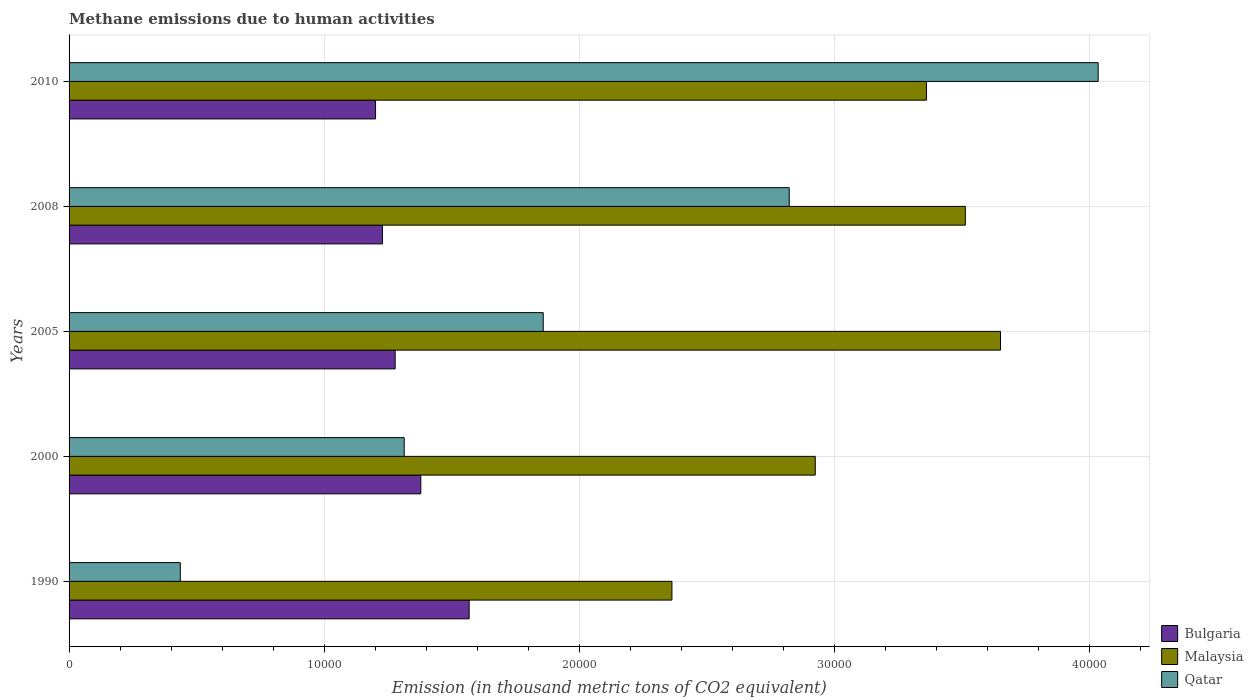How many groups of bars are there?
Offer a terse response. 5. Are the number of bars per tick equal to the number of legend labels?
Make the answer very short. Yes. Are the number of bars on each tick of the Y-axis equal?
Offer a very short reply. Yes. What is the amount of methane emitted in Malaysia in 1990?
Make the answer very short. 2.36e+04. Across all years, what is the maximum amount of methane emitted in Bulgaria?
Your answer should be very brief. 1.57e+04. Across all years, what is the minimum amount of methane emitted in Malaysia?
Give a very brief answer. 2.36e+04. In which year was the amount of methane emitted in Malaysia maximum?
Give a very brief answer. 2005. In which year was the amount of methane emitted in Qatar minimum?
Keep it short and to the point. 1990. What is the total amount of methane emitted in Bulgaria in the graph?
Provide a short and direct response. 6.65e+04. What is the difference between the amount of methane emitted in Bulgaria in 2000 and that in 2005?
Your answer should be very brief. 1004.9. What is the difference between the amount of methane emitted in Qatar in 2005 and the amount of methane emitted in Malaysia in 2000?
Give a very brief answer. -1.07e+04. What is the average amount of methane emitted in Qatar per year?
Offer a terse response. 2.09e+04. In the year 2005, what is the difference between the amount of methane emitted in Malaysia and amount of methane emitted in Qatar?
Your answer should be very brief. 1.79e+04. In how many years, is the amount of methane emitted in Bulgaria greater than 16000 thousand metric tons?
Give a very brief answer. 0. What is the ratio of the amount of methane emitted in Qatar in 2008 to that in 2010?
Ensure brevity in your answer.  0.7. What is the difference between the highest and the second highest amount of methane emitted in Malaysia?
Provide a succinct answer. 1378.2. What is the difference between the highest and the lowest amount of methane emitted in Qatar?
Your answer should be very brief. 3.60e+04. In how many years, is the amount of methane emitted in Qatar greater than the average amount of methane emitted in Qatar taken over all years?
Offer a terse response. 2. What does the 2nd bar from the top in 1990 represents?
Offer a very short reply. Malaysia. What does the 3rd bar from the bottom in 1990 represents?
Provide a short and direct response. Qatar. How many bars are there?
Your answer should be compact. 15. Are all the bars in the graph horizontal?
Keep it short and to the point. Yes. How many years are there in the graph?
Offer a very short reply. 5. How many legend labels are there?
Give a very brief answer. 3. How are the legend labels stacked?
Your answer should be compact. Vertical. What is the title of the graph?
Ensure brevity in your answer.  Methane emissions due to human activities. Does "Lao PDR" appear as one of the legend labels in the graph?
Your response must be concise. No. What is the label or title of the X-axis?
Your answer should be very brief. Emission (in thousand metric tons of CO2 equivalent). What is the Emission (in thousand metric tons of CO2 equivalent) in Bulgaria in 1990?
Provide a succinct answer. 1.57e+04. What is the Emission (in thousand metric tons of CO2 equivalent) in Malaysia in 1990?
Offer a terse response. 2.36e+04. What is the Emission (in thousand metric tons of CO2 equivalent) of Qatar in 1990?
Your answer should be compact. 4358.8. What is the Emission (in thousand metric tons of CO2 equivalent) in Bulgaria in 2000?
Offer a terse response. 1.38e+04. What is the Emission (in thousand metric tons of CO2 equivalent) of Malaysia in 2000?
Offer a terse response. 2.92e+04. What is the Emission (in thousand metric tons of CO2 equivalent) of Qatar in 2000?
Your answer should be very brief. 1.31e+04. What is the Emission (in thousand metric tons of CO2 equivalent) in Bulgaria in 2005?
Your response must be concise. 1.28e+04. What is the Emission (in thousand metric tons of CO2 equivalent) in Malaysia in 2005?
Make the answer very short. 3.65e+04. What is the Emission (in thousand metric tons of CO2 equivalent) of Qatar in 2005?
Your answer should be compact. 1.86e+04. What is the Emission (in thousand metric tons of CO2 equivalent) of Bulgaria in 2008?
Provide a short and direct response. 1.23e+04. What is the Emission (in thousand metric tons of CO2 equivalent) in Malaysia in 2008?
Ensure brevity in your answer.  3.51e+04. What is the Emission (in thousand metric tons of CO2 equivalent) of Qatar in 2008?
Keep it short and to the point. 2.82e+04. What is the Emission (in thousand metric tons of CO2 equivalent) in Bulgaria in 2010?
Provide a short and direct response. 1.20e+04. What is the Emission (in thousand metric tons of CO2 equivalent) in Malaysia in 2010?
Your answer should be compact. 3.36e+04. What is the Emission (in thousand metric tons of CO2 equivalent) in Qatar in 2010?
Ensure brevity in your answer.  4.03e+04. Across all years, what is the maximum Emission (in thousand metric tons of CO2 equivalent) in Bulgaria?
Keep it short and to the point. 1.57e+04. Across all years, what is the maximum Emission (in thousand metric tons of CO2 equivalent) in Malaysia?
Make the answer very short. 3.65e+04. Across all years, what is the maximum Emission (in thousand metric tons of CO2 equivalent) of Qatar?
Offer a terse response. 4.03e+04. Across all years, what is the minimum Emission (in thousand metric tons of CO2 equivalent) in Bulgaria?
Your response must be concise. 1.20e+04. Across all years, what is the minimum Emission (in thousand metric tons of CO2 equivalent) of Malaysia?
Your answer should be compact. 2.36e+04. Across all years, what is the minimum Emission (in thousand metric tons of CO2 equivalent) in Qatar?
Provide a succinct answer. 4358.8. What is the total Emission (in thousand metric tons of CO2 equivalent) in Bulgaria in the graph?
Make the answer very short. 6.65e+04. What is the total Emission (in thousand metric tons of CO2 equivalent) in Malaysia in the graph?
Provide a succinct answer. 1.58e+05. What is the total Emission (in thousand metric tons of CO2 equivalent) in Qatar in the graph?
Provide a short and direct response. 1.05e+05. What is the difference between the Emission (in thousand metric tons of CO2 equivalent) of Bulgaria in 1990 and that in 2000?
Give a very brief answer. 1894.2. What is the difference between the Emission (in thousand metric tons of CO2 equivalent) in Malaysia in 1990 and that in 2000?
Provide a succinct answer. -5617.1. What is the difference between the Emission (in thousand metric tons of CO2 equivalent) in Qatar in 1990 and that in 2000?
Provide a short and direct response. -8774.7. What is the difference between the Emission (in thousand metric tons of CO2 equivalent) of Bulgaria in 1990 and that in 2005?
Ensure brevity in your answer.  2899.1. What is the difference between the Emission (in thousand metric tons of CO2 equivalent) in Malaysia in 1990 and that in 2005?
Offer a very short reply. -1.29e+04. What is the difference between the Emission (in thousand metric tons of CO2 equivalent) in Qatar in 1990 and that in 2005?
Offer a very short reply. -1.42e+04. What is the difference between the Emission (in thousand metric tons of CO2 equivalent) of Bulgaria in 1990 and that in 2008?
Offer a very short reply. 3397.3. What is the difference between the Emission (in thousand metric tons of CO2 equivalent) of Malaysia in 1990 and that in 2008?
Offer a very short reply. -1.15e+04. What is the difference between the Emission (in thousand metric tons of CO2 equivalent) in Qatar in 1990 and that in 2008?
Provide a short and direct response. -2.39e+04. What is the difference between the Emission (in thousand metric tons of CO2 equivalent) of Bulgaria in 1990 and that in 2010?
Provide a succinct answer. 3666.9. What is the difference between the Emission (in thousand metric tons of CO2 equivalent) in Malaysia in 1990 and that in 2010?
Provide a succinct answer. -9974.2. What is the difference between the Emission (in thousand metric tons of CO2 equivalent) of Qatar in 1990 and that in 2010?
Provide a succinct answer. -3.60e+04. What is the difference between the Emission (in thousand metric tons of CO2 equivalent) in Bulgaria in 2000 and that in 2005?
Your answer should be compact. 1004.9. What is the difference between the Emission (in thousand metric tons of CO2 equivalent) in Malaysia in 2000 and that in 2005?
Provide a short and direct response. -7258.7. What is the difference between the Emission (in thousand metric tons of CO2 equivalent) in Qatar in 2000 and that in 2005?
Keep it short and to the point. -5447.2. What is the difference between the Emission (in thousand metric tons of CO2 equivalent) in Bulgaria in 2000 and that in 2008?
Provide a succinct answer. 1503.1. What is the difference between the Emission (in thousand metric tons of CO2 equivalent) in Malaysia in 2000 and that in 2008?
Make the answer very short. -5880.5. What is the difference between the Emission (in thousand metric tons of CO2 equivalent) in Qatar in 2000 and that in 2008?
Your answer should be very brief. -1.51e+04. What is the difference between the Emission (in thousand metric tons of CO2 equivalent) in Bulgaria in 2000 and that in 2010?
Your answer should be compact. 1772.7. What is the difference between the Emission (in thousand metric tons of CO2 equivalent) of Malaysia in 2000 and that in 2010?
Offer a terse response. -4357.1. What is the difference between the Emission (in thousand metric tons of CO2 equivalent) of Qatar in 2000 and that in 2010?
Offer a terse response. -2.72e+04. What is the difference between the Emission (in thousand metric tons of CO2 equivalent) in Bulgaria in 2005 and that in 2008?
Your response must be concise. 498.2. What is the difference between the Emission (in thousand metric tons of CO2 equivalent) of Malaysia in 2005 and that in 2008?
Offer a terse response. 1378.2. What is the difference between the Emission (in thousand metric tons of CO2 equivalent) of Qatar in 2005 and that in 2008?
Your answer should be very brief. -9640.9. What is the difference between the Emission (in thousand metric tons of CO2 equivalent) in Bulgaria in 2005 and that in 2010?
Ensure brevity in your answer.  767.8. What is the difference between the Emission (in thousand metric tons of CO2 equivalent) of Malaysia in 2005 and that in 2010?
Keep it short and to the point. 2901.6. What is the difference between the Emission (in thousand metric tons of CO2 equivalent) in Qatar in 2005 and that in 2010?
Your response must be concise. -2.17e+04. What is the difference between the Emission (in thousand metric tons of CO2 equivalent) of Bulgaria in 2008 and that in 2010?
Provide a succinct answer. 269.6. What is the difference between the Emission (in thousand metric tons of CO2 equivalent) of Malaysia in 2008 and that in 2010?
Your answer should be very brief. 1523.4. What is the difference between the Emission (in thousand metric tons of CO2 equivalent) in Qatar in 2008 and that in 2010?
Your answer should be very brief. -1.21e+04. What is the difference between the Emission (in thousand metric tons of CO2 equivalent) of Bulgaria in 1990 and the Emission (in thousand metric tons of CO2 equivalent) of Malaysia in 2000?
Offer a terse response. -1.36e+04. What is the difference between the Emission (in thousand metric tons of CO2 equivalent) of Bulgaria in 1990 and the Emission (in thousand metric tons of CO2 equivalent) of Qatar in 2000?
Give a very brief answer. 2544. What is the difference between the Emission (in thousand metric tons of CO2 equivalent) of Malaysia in 1990 and the Emission (in thousand metric tons of CO2 equivalent) of Qatar in 2000?
Offer a terse response. 1.05e+04. What is the difference between the Emission (in thousand metric tons of CO2 equivalent) in Bulgaria in 1990 and the Emission (in thousand metric tons of CO2 equivalent) in Malaysia in 2005?
Your answer should be very brief. -2.08e+04. What is the difference between the Emission (in thousand metric tons of CO2 equivalent) of Bulgaria in 1990 and the Emission (in thousand metric tons of CO2 equivalent) of Qatar in 2005?
Give a very brief answer. -2903.2. What is the difference between the Emission (in thousand metric tons of CO2 equivalent) of Malaysia in 1990 and the Emission (in thousand metric tons of CO2 equivalent) of Qatar in 2005?
Your answer should be very brief. 5043.9. What is the difference between the Emission (in thousand metric tons of CO2 equivalent) of Bulgaria in 1990 and the Emission (in thousand metric tons of CO2 equivalent) of Malaysia in 2008?
Your answer should be compact. -1.94e+04. What is the difference between the Emission (in thousand metric tons of CO2 equivalent) of Bulgaria in 1990 and the Emission (in thousand metric tons of CO2 equivalent) of Qatar in 2008?
Offer a very short reply. -1.25e+04. What is the difference between the Emission (in thousand metric tons of CO2 equivalent) of Malaysia in 1990 and the Emission (in thousand metric tons of CO2 equivalent) of Qatar in 2008?
Give a very brief answer. -4597. What is the difference between the Emission (in thousand metric tons of CO2 equivalent) in Bulgaria in 1990 and the Emission (in thousand metric tons of CO2 equivalent) in Malaysia in 2010?
Offer a very short reply. -1.79e+04. What is the difference between the Emission (in thousand metric tons of CO2 equivalent) of Bulgaria in 1990 and the Emission (in thousand metric tons of CO2 equivalent) of Qatar in 2010?
Give a very brief answer. -2.47e+04. What is the difference between the Emission (in thousand metric tons of CO2 equivalent) in Malaysia in 1990 and the Emission (in thousand metric tons of CO2 equivalent) in Qatar in 2010?
Keep it short and to the point. -1.67e+04. What is the difference between the Emission (in thousand metric tons of CO2 equivalent) in Bulgaria in 2000 and the Emission (in thousand metric tons of CO2 equivalent) in Malaysia in 2005?
Your response must be concise. -2.27e+04. What is the difference between the Emission (in thousand metric tons of CO2 equivalent) of Bulgaria in 2000 and the Emission (in thousand metric tons of CO2 equivalent) of Qatar in 2005?
Keep it short and to the point. -4797.4. What is the difference between the Emission (in thousand metric tons of CO2 equivalent) in Malaysia in 2000 and the Emission (in thousand metric tons of CO2 equivalent) in Qatar in 2005?
Give a very brief answer. 1.07e+04. What is the difference between the Emission (in thousand metric tons of CO2 equivalent) of Bulgaria in 2000 and the Emission (in thousand metric tons of CO2 equivalent) of Malaysia in 2008?
Keep it short and to the point. -2.13e+04. What is the difference between the Emission (in thousand metric tons of CO2 equivalent) in Bulgaria in 2000 and the Emission (in thousand metric tons of CO2 equivalent) in Qatar in 2008?
Your answer should be very brief. -1.44e+04. What is the difference between the Emission (in thousand metric tons of CO2 equivalent) of Malaysia in 2000 and the Emission (in thousand metric tons of CO2 equivalent) of Qatar in 2008?
Your answer should be very brief. 1020.1. What is the difference between the Emission (in thousand metric tons of CO2 equivalent) of Bulgaria in 2000 and the Emission (in thousand metric tons of CO2 equivalent) of Malaysia in 2010?
Offer a terse response. -1.98e+04. What is the difference between the Emission (in thousand metric tons of CO2 equivalent) in Bulgaria in 2000 and the Emission (in thousand metric tons of CO2 equivalent) in Qatar in 2010?
Offer a very short reply. -2.65e+04. What is the difference between the Emission (in thousand metric tons of CO2 equivalent) in Malaysia in 2000 and the Emission (in thousand metric tons of CO2 equivalent) in Qatar in 2010?
Ensure brevity in your answer.  -1.11e+04. What is the difference between the Emission (in thousand metric tons of CO2 equivalent) in Bulgaria in 2005 and the Emission (in thousand metric tons of CO2 equivalent) in Malaysia in 2008?
Make the answer very short. -2.23e+04. What is the difference between the Emission (in thousand metric tons of CO2 equivalent) of Bulgaria in 2005 and the Emission (in thousand metric tons of CO2 equivalent) of Qatar in 2008?
Provide a succinct answer. -1.54e+04. What is the difference between the Emission (in thousand metric tons of CO2 equivalent) in Malaysia in 2005 and the Emission (in thousand metric tons of CO2 equivalent) in Qatar in 2008?
Make the answer very short. 8278.8. What is the difference between the Emission (in thousand metric tons of CO2 equivalent) of Bulgaria in 2005 and the Emission (in thousand metric tons of CO2 equivalent) of Malaysia in 2010?
Ensure brevity in your answer.  -2.08e+04. What is the difference between the Emission (in thousand metric tons of CO2 equivalent) in Bulgaria in 2005 and the Emission (in thousand metric tons of CO2 equivalent) in Qatar in 2010?
Provide a succinct answer. -2.75e+04. What is the difference between the Emission (in thousand metric tons of CO2 equivalent) of Malaysia in 2005 and the Emission (in thousand metric tons of CO2 equivalent) of Qatar in 2010?
Give a very brief answer. -3827.8. What is the difference between the Emission (in thousand metric tons of CO2 equivalent) of Bulgaria in 2008 and the Emission (in thousand metric tons of CO2 equivalent) of Malaysia in 2010?
Ensure brevity in your answer.  -2.13e+04. What is the difference between the Emission (in thousand metric tons of CO2 equivalent) in Bulgaria in 2008 and the Emission (in thousand metric tons of CO2 equivalent) in Qatar in 2010?
Give a very brief answer. -2.80e+04. What is the difference between the Emission (in thousand metric tons of CO2 equivalent) in Malaysia in 2008 and the Emission (in thousand metric tons of CO2 equivalent) in Qatar in 2010?
Your answer should be very brief. -5206. What is the average Emission (in thousand metric tons of CO2 equivalent) of Bulgaria per year?
Keep it short and to the point. 1.33e+04. What is the average Emission (in thousand metric tons of CO2 equivalent) in Malaysia per year?
Your response must be concise. 3.16e+04. What is the average Emission (in thousand metric tons of CO2 equivalent) in Qatar per year?
Provide a succinct answer. 2.09e+04. In the year 1990, what is the difference between the Emission (in thousand metric tons of CO2 equivalent) in Bulgaria and Emission (in thousand metric tons of CO2 equivalent) in Malaysia?
Offer a very short reply. -7947.1. In the year 1990, what is the difference between the Emission (in thousand metric tons of CO2 equivalent) of Bulgaria and Emission (in thousand metric tons of CO2 equivalent) of Qatar?
Offer a very short reply. 1.13e+04. In the year 1990, what is the difference between the Emission (in thousand metric tons of CO2 equivalent) of Malaysia and Emission (in thousand metric tons of CO2 equivalent) of Qatar?
Provide a short and direct response. 1.93e+04. In the year 2000, what is the difference between the Emission (in thousand metric tons of CO2 equivalent) of Bulgaria and Emission (in thousand metric tons of CO2 equivalent) of Malaysia?
Your answer should be very brief. -1.55e+04. In the year 2000, what is the difference between the Emission (in thousand metric tons of CO2 equivalent) in Bulgaria and Emission (in thousand metric tons of CO2 equivalent) in Qatar?
Offer a terse response. 649.8. In the year 2000, what is the difference between the Emission (in thousand metric tons of CO2 equivalent) in Malaysia and Emission (in thousand metric tons of CO2 equivalent) in Qatar?
Keep it short and to the point. 1.61e+04. In the year 2005, what is the difference between the Emission (in thousand metric tons of CO2 equivalent) in Bulgaria and Emission (in thousand metric tons of CO2 equivalent) in Malaysia?
Your response must be concise. -2.37e+04. In the year 2005, what is the difference between the Emission (in thousand metric tons of CO2 equivalent) in Bulgaria and Emission (in thousand metric tons of CO2 equivalent) in Qatar?
Your response must be concise. -5802.3. In the year 2005, what is the difference between the Emission (in thousand metric tons of CO2 equivalent) in Malaysia and Emission (in thousand metric tons of CO2 equivalent) in Qatar?
Make the answer very short. 1.79e+04. In the year 2008, what is the difference between the Emission (in thousand metric tons of CO2 equivalent) of Bulgaria and Emission (in thousand metric tons of CO2 equivalent) of Malaysia?
Ensure brevity in your answer.  -2.28e+04. In the year 2008, what is the difference between the Emission (in thousand metric tons of CO2 equivalent) in Bulgaria and Emission (in thousand metric tons of CO2 equivalent) in Qatar?
Your response must be concise. -1.59e+04. In the year 2008, what is the difference between the Emission (in thousand metric tons of CO2 equivalent) of Malaysia and Emission (in thousand metric tons of CO2 equivalent) of Qatar?
Offer a very short reply. 6900.6. In the year 2010, what is the difference between the Emission (in thousand metric tons of CO2 equivalent) of Bulgaria and Emission (in thousand metric tons of CO2 equivalent) of Malaysia?
Provide a succinct answer. -2.16e+04. In the year 2010, what is the difference between the Emission (in thousand metric tons of CO2 equivalent) of Bulgaria and Emission (in thousand metric tons of CO2 equivalent) of Qatar?
Make the answer very short. -2.83e+04. In the year 2010, what is the difference between the Emission (in thousand metric tons of CO2 equivalent) of Malaysia and Emission (in thousand metric tons of CO2 equivalent) of Qatar?
Give a very brief answer. -6729.4. What is the ratio of the Emission (in thousand metric tons of CO2 equivalent) in Bulgaria in 1990 to that in 2000?
Provide a succinct answer. 1.14. What is the ratio of the Emission (in thousand metric tons of CO2 equivalent) of Malaysia in 1990 to that in 2000?
Make the answer very short. 0.81. What is the ratio of the Emission (in thousand metric tons of CO2 equivalent) in Qatar in 1990 to that in 2000?
Make the answer very short. 0.33. What is the ratio of the Emission (in thousand metric tons of CO2 equivalent) in Bulgaria in 1990 to that in 2005?
Keep it short and to the point. 1.23. What is the ratio of the Emission (in thousand metric tons of CO2 equivalent) of Malaysia in 1990 to that in 2005?
Provide a succinct answer. 0.65. What is the ratio of the Emission (in thousand metric tons of CO2 equivalent) in Qatar in 1990 to that in 2005?
Make the answer very short. 0.23. What is the ratio of the Emission (in thousand metric tons of CO2 equivalent) in Bulgaria in 1990 to that in 2008?
Keep it short and to the point. 1.28. What is the ratio of the Emission (in thousand metric tons of CO2 equivalent) in Malaysia in 1990 to that in 2008?
Offer a terse response. 0.67. What is the ratio of the Emission (in thousand metric tons of CO2 equivalent) in Qatar in 1990 to that in 2008?
Offer a terse response. 0.15. What is the ratio of the Emission (in thousand metric tons of CO2 equivalent) in Bulgaria in 1990 to that in 2010?
Your answer should be very brief. 1.31. What is the ratio of the Emission (in thousand metric tons of CO2 equivalent) in Malaysia in 1990 to that in 2010?
Your answer should be very brief. 0.7. What is the ratio of the Emission (in thousand metric tons of CO2 equivalent) in Qatar in 1990 to that in 2010?
Provide a succinct answer. 0.11. What is the ratio of the Emission (in thousand metric tons of CO2 equivalent) of Bulgaria in 2000 to that in 2005?
Provide a succinct answer. 1.08. What is the ratio of the Emission (in thousand metric tons of CO2 equivalent) in Malaysia in 2000 to that in 2005?
Give a very brief answer. 0.8. What is the ratio of the Emission (in thousand metric tons of CO2 equivalent) of Qatar in 2000 to that in 2005?
Your answer should be very brief. 0.71. What is the ratio of the Emission (in thousand metric tons of CO2 equivalent) in Bulgaria in 2000 to that in 2008?
Your answer should be very brief. 1.12. What is the ratio of the Emission (in thousand metric tons of CO2 equivalent) of Malaysia in 2000 to that in 2008?
Offer a terse response. 0.83. What is the ratio of the Emission (in thousand metric tons of CO2 equivalent) in Qatar in 2000 to that in 2008?
Provide a short and direct response. 0.47. What is the ratio of the Emission (in thousand metric tons of CO2 equivalent) of Bulgaria in 2000 to that in 2010?
Provide a short and direct response. 1.15. What is the ratio of the Emission (in thousand metric tons of CO2 equivalent) in Malaysia in 2000 to that in 2010?
Keep it short and to the point. 0.87. What is the ratio of the Emission (in thousand metric tons of CO2 equivalent) of Qatar in 2000 to that in 2010?
Provide a short and direct response. 0.33. What is the ratio of the Emission (in thousand metric tons of CO2 equivalent) in Bulgaria in 2005 to that in 2008?
Provide a succinct answer. 1.04. What is the ratio of the Emission (in thousand metric tons of CO2 equivalent) in Malaysia in 2005 to that in 2008?
Make the answer very short. 1.04. What is the ratio of the Emission (in thousand metric tons of CO2 equivalent) of Qatar in 2005 to that in 2008?
Provide a short and direct response. 0.66. What is the ratio of the Emission (in thousand metric tons of CO2 equivalent) in Bulgaria in 2005 to that in 2010?
Keep it short and to the point. 1.06. What is the ratio of the Emission (in thousand metric tons of CO2 equivalent) of Malaysia in 2005 to that in 2010?
Make the answer very short. 1.09. What is the ratio of the Emission (in thousand metric tons of CO2 equivalent) of Qatar in 2005 to that in 2010?
Keep it short and to the point. 0.46. What is the ratio of the Emission (in thousand metric tons of CO2 equivalent) in Bulgaria in 2008 to that in 2010?
Offer a terse response. 1.02. What is the ratio of the Emission (in thousand metric tons of CO2 equivalent) of Malaysia in 2008 to that in 2010?
Give a very brief answer. 1.05. What is the ratio of the Emission (in thousand metric tons of CO2 equivalent) in Qatar in 2008 to that in 2010?
Your answer should be very brief. 0.7. What is the difference between the highest and the second highest Emission (in thousand metric tons of CO2 equivalent) in Bulgaria?
Give a very brief answer. 1894.2. What is the difference between the highest and the second highest Emission (in thousand metric tons of CO2 equivalent) of Malaysia?
Make the answer very short. 1378.2. What is the difference between the highest and the second highest Emission (in thousand metric tons of CO2 equivalent) in Qatar?
Give a very brief answer. 1.21e+04. What is the difference between the highest and the lowest Emission (in thousand metric tons of CO2 equivalent) of Bulgaria?
Offer a terse response. 3666.9. What is the difference between the highest and the lowest Emission (in thousand metric tons of CO2 equivalent) of Malaysia?
Give a very brief answer. 1.29e+04. What is the difference between the highest and the lowest Emission (in thousand metric tons of CO2 equivalent) in Qatar?
Give a very brief answer. 3.60e+04. 